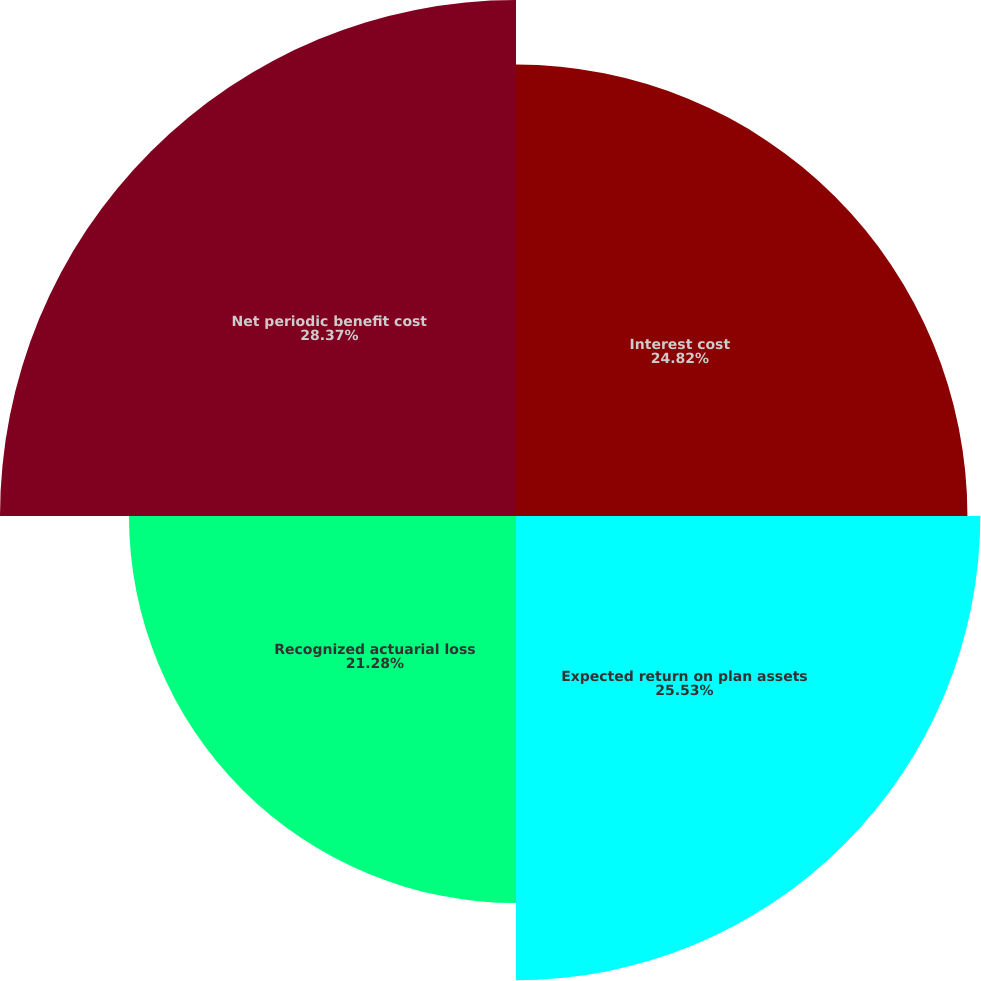Convert chart. <chart><loc_0><loc_0><loc_500><loc_500><pie_chart><fcel>Interest cost<fcel>Expected return on plan assets<fcel>Recognized actuarial loss<fcel>Net periodic benefit cost<nl><fcel>24.82%<fcel>25.53%<fcel>21.28%<fcel>28.37%<nl></chart> 